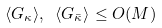<formula> <loc_0><loc_0><loc_500><loc_500>\langle G _ { \kappa } \rangle , \ \langle G _ { \bar { \kappa } } \rangle \leq O ( M )</formula> 